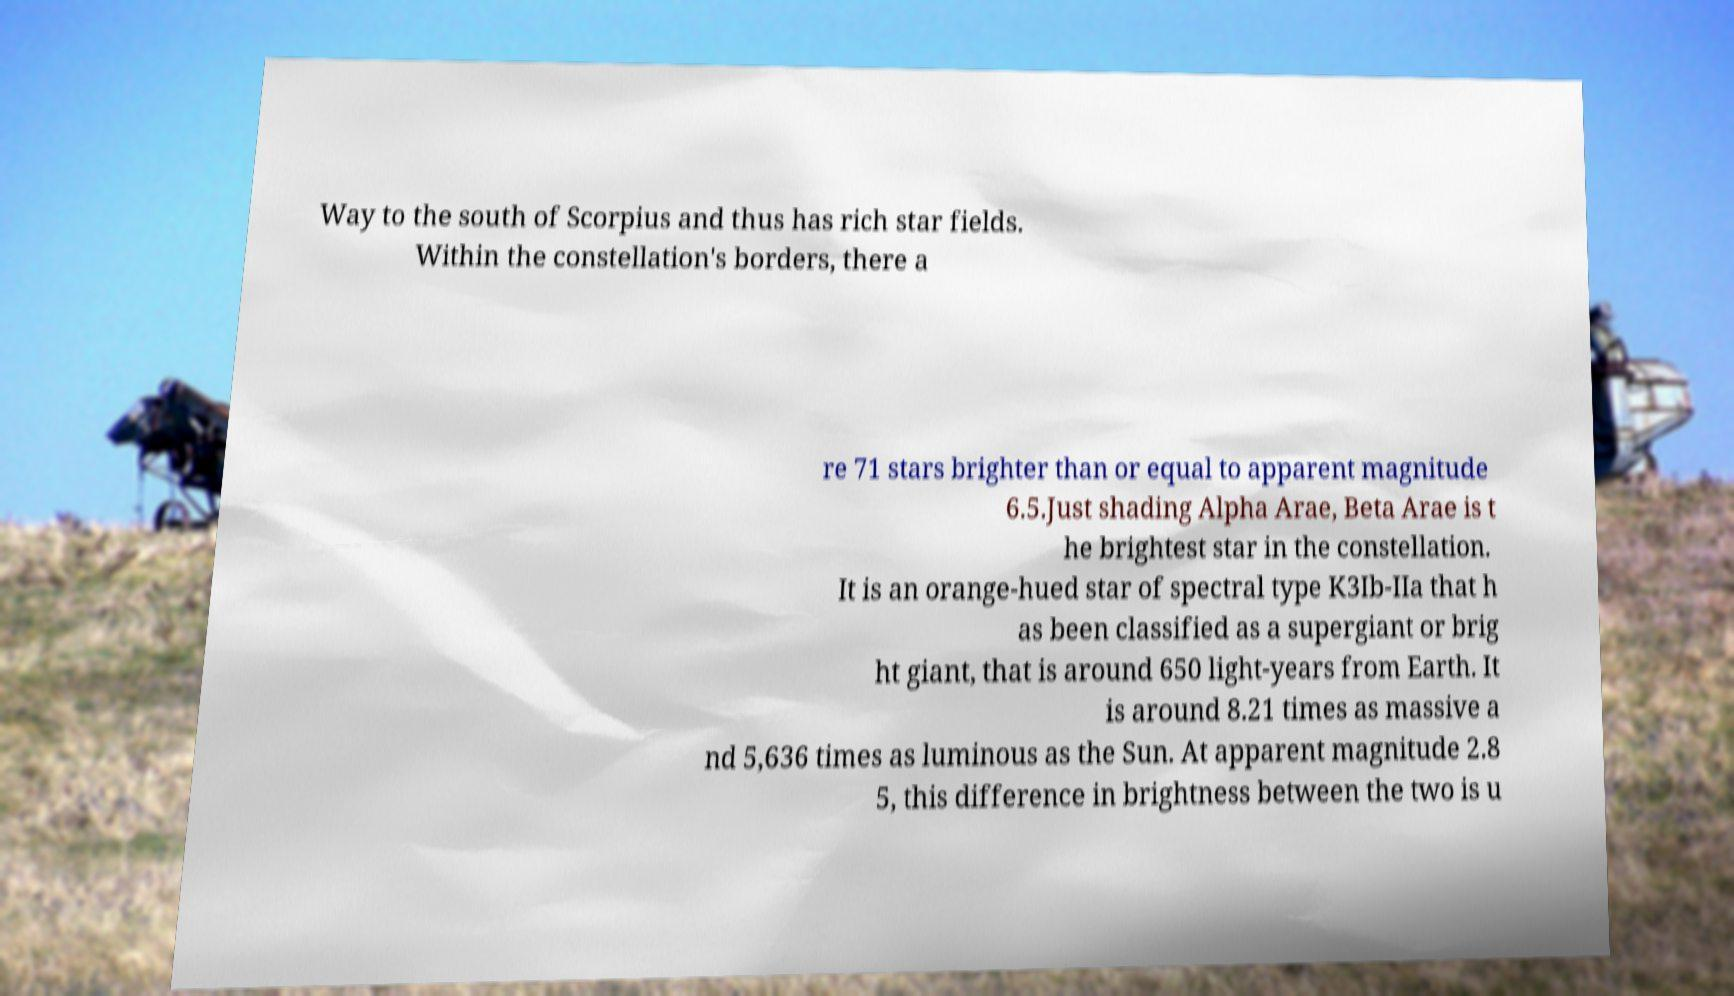There's text embedded in this image that I need extracted. Can you transcribe it verbatim? Way to the south of Scorpius and thus has rich star fields. Within the constellation's borders, there a re 71 stars brighter than or equal to apparent magnitude 6.5.Just shading Alpha Arae, Beta Arae is t he brightest star in the constellation. It is an orange-hued star of spectral type K3Ib-IIa that h as been classified as a supergiant or brig ht giant, that is around 650 light-years from Earth. It is around 8.21 times as massive a nd 5,636 times as luminous as the Sun. At apparent magnitude 2.8 5, this difference in brightness between the two is u 